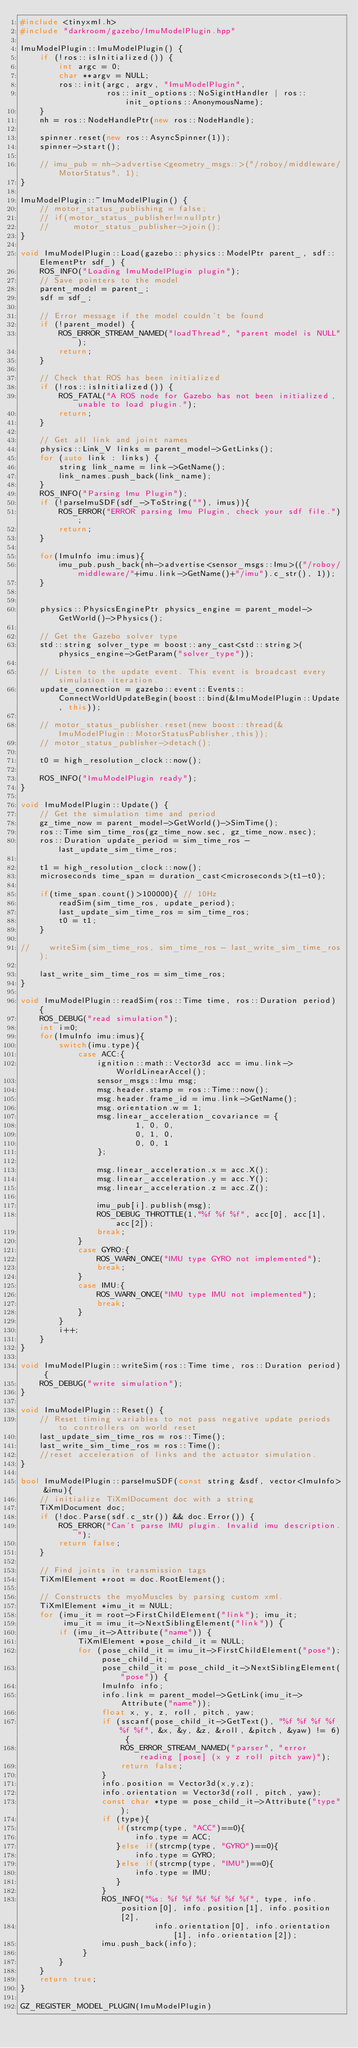<code> <loc_0><loc_0><loc_500><loc_500><_C++_>#include <tinyxml.h>
#include "darkroom/gazebo/ImuModelPlugin.hpp"

ImuModelPlugin::ImuModelPlugin() {
    if (!ros::isInitialized()) {
        int argc = 0;
        char **argv = NULL;
        ros::init(argc, argv, "ImuModelPlugin",
                  ros::init_options::NoSigintHandler | ros::init_options::AnonymousName);
    }
    nh = ros::NodeHandlePtr(new ros::NodeHandle);

    spinner.reset(new ros::AsyncSpinner(1));
    spinner->start();

    // imu_pub = nh->advertise<geometry_msgs::>("/roboy/middleware/MotorStatus", 1);
}

ImuModelPlugin::~ImuModelPlugin() {
    // motor_status_publishing = false;
    // if(motor_status_publisher!=nullptr)
    //     motor_status_publisher->join();
}

void ImuModelPlugin::Load(gazebo::physics::ModelPtr parent_, sdf::ElementPtr sdf_) {
    ROS_INFO("Loading ImuModelPlugin plugin");
    // Save pointers to the model
    parent_model = parent_;
    sdf = sdf_;

    // Error message if the model couldn't be found
    if (!parent_model) {
        ROS_ERROR_STREAM_NAMED("loadThread", "parent model is NULL");
        return;
    }

    // Check that ROS has been initialized
    if (!ros::isInitialized()) {
        ROS_FATAL("A ROS node for Gazebo has not been initialized, unable to load plugin.");
        return;
    }

    // Get all link and joint names
    physics::Link_V links = parent_model->GetLinks();
    for (auto link : links) {
        string link_name = link->GetName();
        link_names.push_back(link_name);
    }
    ROS_INFO("Parsing Imu Plugin");
    if (!parseImuSDF(sdf_->ToString(""), imus)){
        ROS_ERROR("ERROR parsing Imu Plugin, check your sdf file.");
        return;
    }

    for(ImuInfo imu:imus){
        imu_pub.push_back(nh->advertise<sensor_msgs::Imu>(("/roboy/middleware/"+imu.link->GetName()+"/imu").c_str(), 1));
    }


    physics::PhysicsEnginePtr physics_engine = parent_model->GetWorld()->Physics();

    // Get the Gazebo solver type
    std::string solver_type = boost::any_cast<std::string>(physics_engine->GetParam("solver_type"));

    // Listen to the update event. This event is broadcast every simulation iteration.
    update_connection = gazebo::event::Events::ConnectWorldUpdateBegin(boost::bind(&ImuModelPlugin::Update, this));

    // motor_status_publisher.reset(new boost::thread(&ImuModelPlugin::MotorStatusPublisher,this));
    // motor_status_publisher->detach();

    t0 = high_resolution_clock::now();

    ROS_INFO("ImuModelPlugin ready");
}

void ImuModelPlugin::Update() {
    // Get the simulation time and period
    gz_time_now = parent_model->GetWorld()->SimTime();
    ros::Time sim_time_ros(gz_time_now.sec, gz_time_now.nsec);
    ros::Duration update_period = sim_time_ros - last_update_sim_time_ros;

    t1 = high_resolution_clock::now();
    microseconds time_span = duration_cast<microseconds>(t1-t0);

    if(time_span.count()>100000){ // 10Hz
        readSim(sim_time_ros, update_period);
        last_update_sim_time_ros = sim_time_ros;
        t0 = t1;
    }

//    writeSim(sim_time_ros, sim_time_ros - last_write_sim_time_ros);

    last_write_sim_time_ros = sim_time_ros;
}

void ImuModelPlugin::readSim(ros::Time time, ros::Duration period) {
    ROS_DEBUG("read simulation");
    int i=0;
    for(ImuInfo imu:imus){
        switch(imu.type){
            case ACC:{
                ignition::math::Vector3d acc = imu.link->WorldLinearAccel();
                sensor_msgs::Imu msg;
                msg.header.stamp = ros::Time::now();
                msg.header.frame_id = imu.link->GetName();
                msg.orientation.w = 1;
                msg.linear_acceleration_covariance = {
                        1, 0, 0,
                        0, 1, 0,
                        0, 0, 1
                };

                msg.linear_acceleration.x = acc.X();
                msg.linear_acceleration.y = acc.Y();
                msg.linear_acceleration.z = acc.Z();

                imu_pub[i].publish(msg);
                ROS_DEBUG_THROTTLE(1,"%f %f %f", acc[0], acc[1], acc[2]);
                break;
            }
            case GYRO:{
                ROS_WARN_ONCE("IMU type GYRO not implemented");
                break;
            }
            case IMU:{
                ROS_WARN_ONCE("IMU type IMU not implemented");
                break;
            }
        }
        i++;
    }
}

void ImuModelPlugin::writeSim(ros::Time time, ros::Duration period) {
    ROS_DEBUG("write simulation");
}

void ImuModelPlugin::Reset() {
    // Reset timing variables to not pass negative update periods to controllers on world reset
    last_update_sim_time_ros = ros::Time();
    last_write_sim_time_ros = ros::Time();
    //reset acceleration of links and the actuator simulation.
}

bool ImuModelPlugin::parseImuSDF(const string &sdf, vector<ImuInfo> &imu){
    // initialize TiXmlDocument doc with a string
    TiXmlDocument doc;
    if (!doc.Parse(sdf.c_str()) && doc.Error()) {
        ROS_ERROR("Can't parse IMU plugin. Invalid imu description.");
        return false;
    }

    // Find joints in transmission tags
    TiXmlElement *root = doc.RootElement();

    // Constructs the myoMuscles by parsing custom xml.
    TiXmlElement *imu_it = NULL;
    for (imu_it = root->FirstChildElement("link"); imu_it;
         imu_it = imu_it->NextSiblingElement("link")) {
        if (imu_it->Attribute("name")) {
            TiXmlElement *pose_child_it = NULL;
            for (pose_child_it = imu_it->FirstChildElement("pose"); pose_child_it;
                 pose_child_it = pose_child_it->NextSiblingElement("pose")) {
                 ImuInfo info;
                 info.link = parent_model->GetLink(imu_it->Attribute("name"));
                 float x, y, z, roll, pitch, yaw;
                 if (sscanf(pose_child_it->GetText(), "%f %f %f %f %f %f", &x, &y, &z, &roll, &pitch, &yaw) != 6) {
                     ROS_ERROR_STREAM_NAMED("parser", "error reading [pose] (x y z roll pitch yaw)");
                     return false;
                 }
                 info.position = Vector3d(x,y,z);
                 info.orientation = Vector3d(roll, pitch, yaw);
                 const char *type = pose_child_it->Attribute("type");
                 if (type){
                    if(strcmp(type, "ACC")==0){
                        info.type = ACC;
                    }else if(strcmp(type, "GYRO")==0){
                        info.type = GYRO;
                    }else if(strcmp(type, "IMU")==0){
                        info.type = IMU;
                    }
                 }
                 ROS_INFO("%s: %f %f %f %f %f %f", type, info.position[0], info.position[1], info.position[2],
                            info.orientation[0], info.orientation[1], info.orientation[2]);
                 imu.push_back(info);
             }
        }
    }
    return true;
}

GZ_REGISTER_MODEL_PLUGIN(ImuModelPlugin)
</code> 